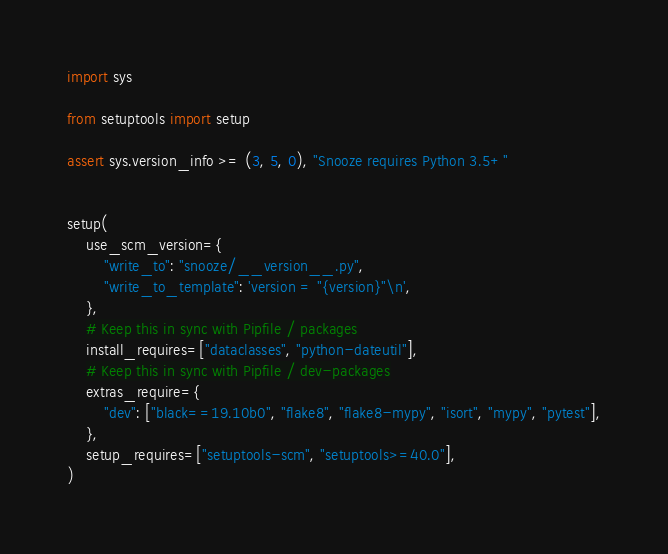<code> <loc_0><loc_0><loc_500><loc_500><_Python_>import sys

from setuptools import setup

assert sys.version_info >= (3, 5, 0), "Snooze requires Python 3.5+"


setup(
    use_scm_version={
        "write_to": "snooze/__version__.py",
        "write_to_template": 'version = "{version}"\n',
    },
    # Keep this in sync with Pipfile / packages
    install_requires=["dataclasses", "python-dateutil"],
    # Keep this in sync with Pipfile / dev-packages
    extras_require={
        "dev": ["black==19.10b0", "flake8", "flake8-mypy", "isort", "mypy", "pytest"],
    },
    setup_requires=["setuptools-scm", "setuptools>=40.0"],
)
</code> 